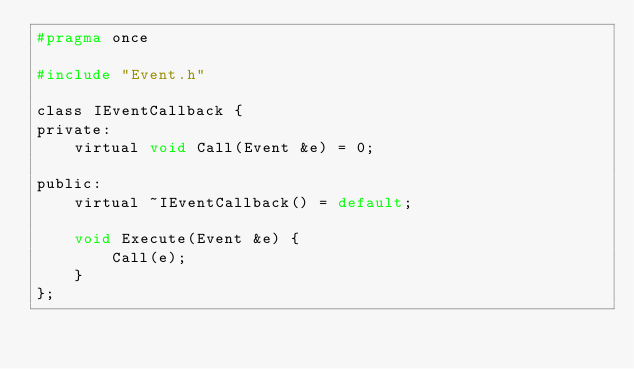<code> <loc_0><loc_0><loc_500><loc_500><_C_>#pragma once

#include "Event.h"

class IEventCallback {
private:
    virtual void Call(Event &e) = 0;

public:
    virtual ~IEventCallback() = default;

    void Execute(Event &e) {
        Call(e);
    }
};</code> 